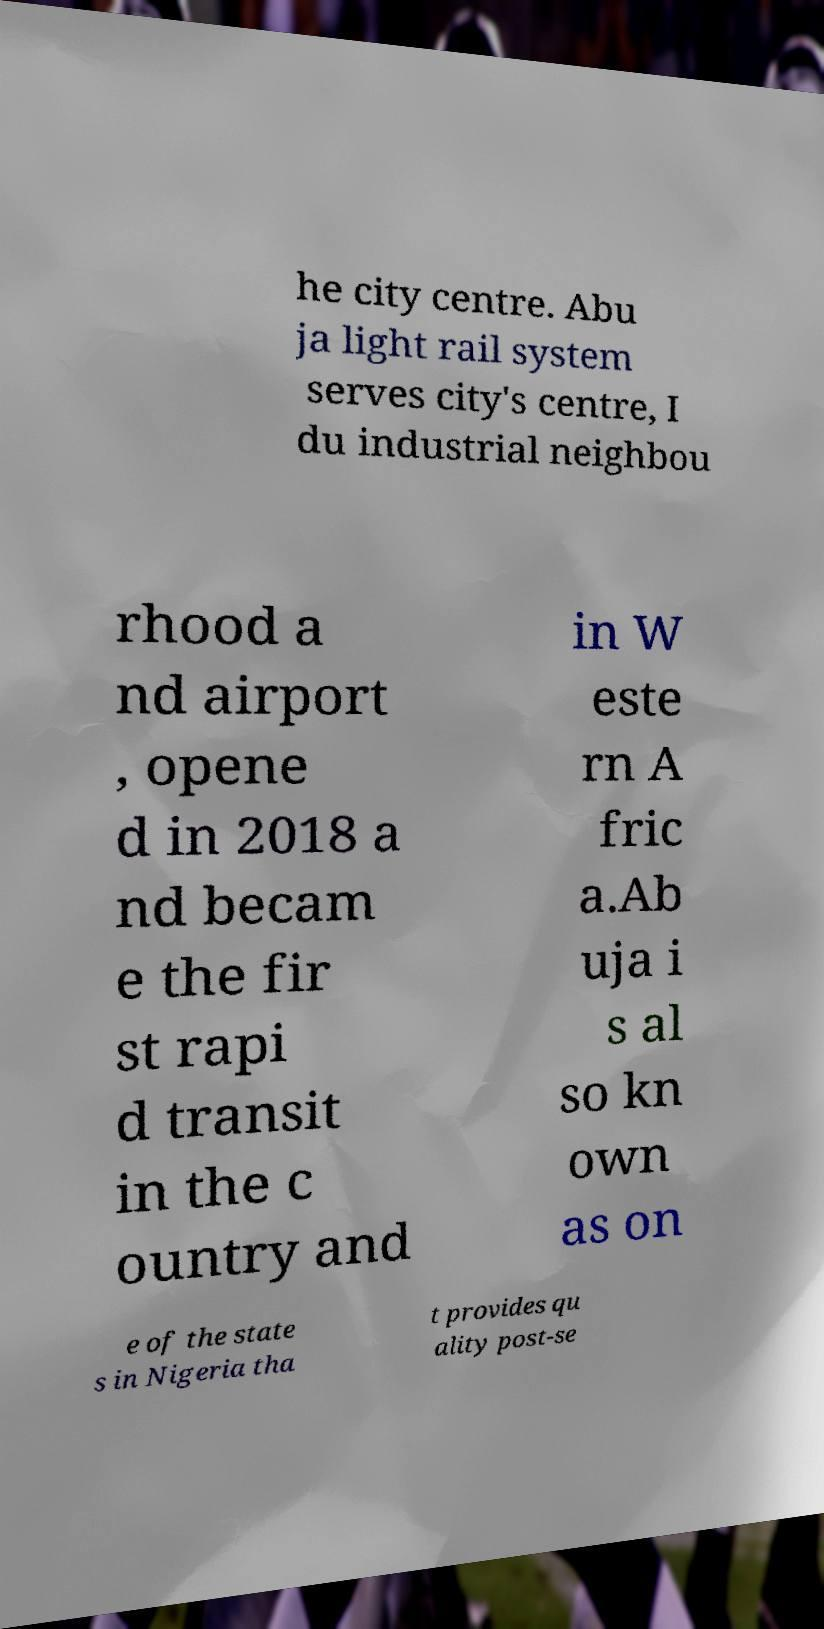For documentation purposes, I need the text within this image transcribed. Could you provide that? he city centre. Abu ja light rail system serves city's centre, I du industrial neighbou rhood a nd airport , opene d in 2018 a nd becam e the fir st rapi d transit in the c ountry and in W este rn A fric a.Ab uja i s al so kn own as on e of the state s in Nigeria tha t provides qu ality post-se 